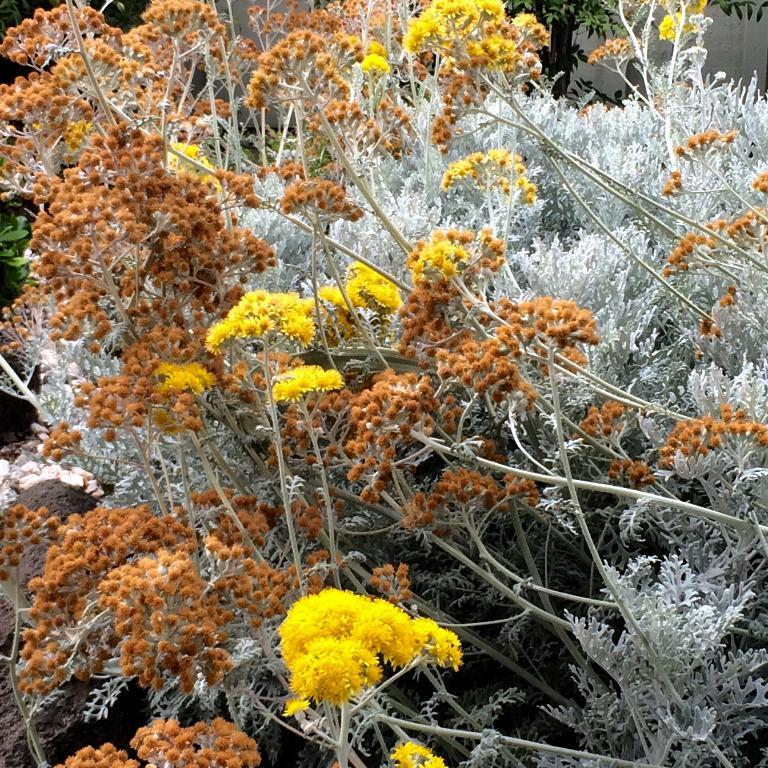What type of living organism is present in the image? There is a plant in the image. What color are the flowers on the plant? The plant has yellow flowers and light brown flowers. Where is the nest located in the image? There is no nest present in the image. How many pigs can be seen in the image? There are no pigs present in the image. 